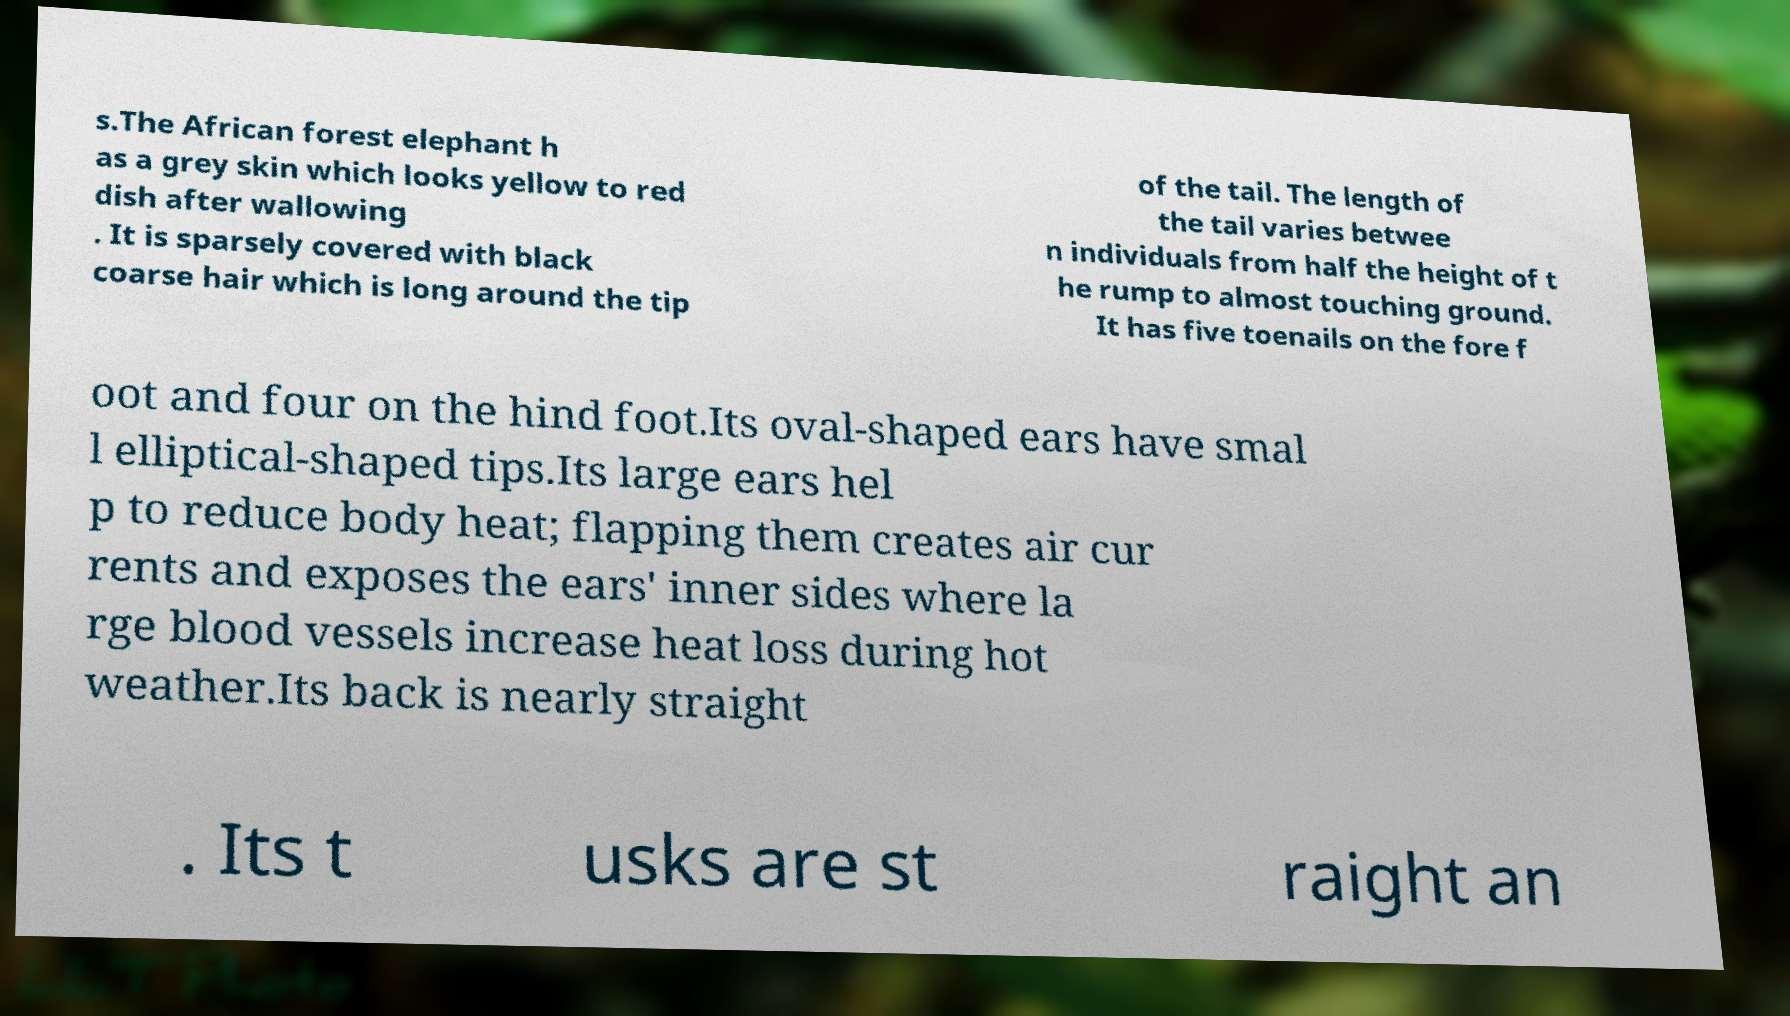Could you extract and type out the text from this image? s.The African forest elephant h as a grey skin which looks yellow to red dish after wallowing . It is sparsely covered with black coarse hair which is long around the tip of the tail. The length of the tail varies betwee n individuals from half the height of t he rump to almost touching ground. It has five toenails on the fore f oot and four on the hind foot.Its oval-shaped ears have smal l elliptical-shaped tips.Its large ears hel p to reduce body heat; flapping them creates air cur rents and exposes the ears' inner sides where la rge blood vessels increase heat loss during hot weather.Its back is nearly straight . Its t usks are st raight an 